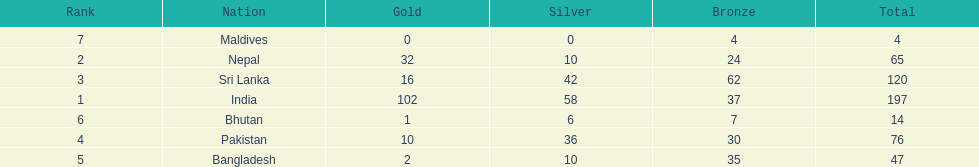How many countries have one more than 10 gold medals? 3. 